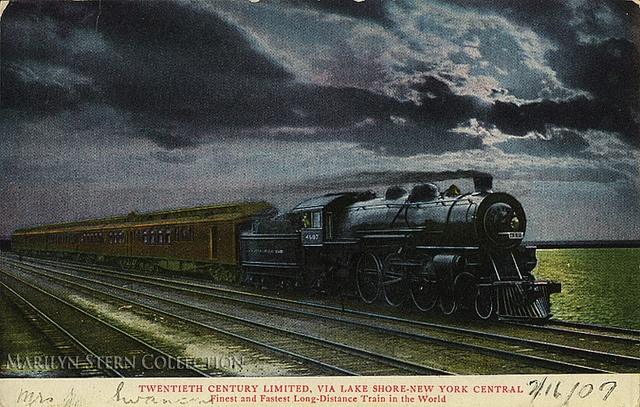Describe the objects in this image and their specific colors. I can see a train in black, gray, darkgreen, and purple tones in this image. 